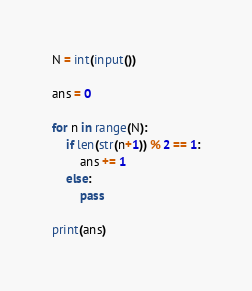Convert code to text. <code><loc_0><loc_0><loc_500><loc_500><_Python_>N = int(input())

ans = 0

for n in range(N):
    if len(str(n+1)) % 2 == 1:
        ans += 1
    else:
        pass

print(ans)</code> 